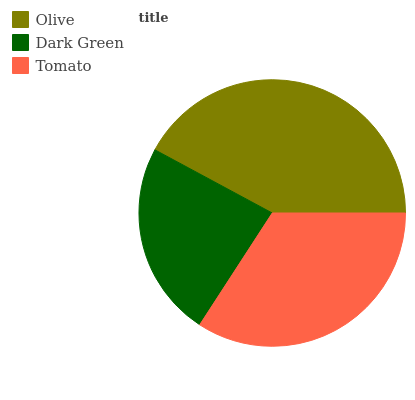Is Dark Green the minimum?
Answer yes or no. Yes. Is Olive the maximum?
Answer yes or no. Yes. Is Tomato the minimum?
Answer yes or no. No. Is Tomato the maximum?
Answer yes or no. No. Is Tomato greater than Dark Green?
Answer yes or no. Yes. Is Dark Green less than Tomato?
Answer yes or no. Yes. Is Dark Green greater than Tomato?
Answer yes or no. No. Is Tomato less than Dark Green?
Answer yes or no. No. Is Tomato the high median?
Answer yes or no. Yes. Is Tomato the low median?
Answer yes or no. Yes. Is Olive the high median?
Answer yes or no. No. Is Dark Green the low median?
Answer yes or no. No. 